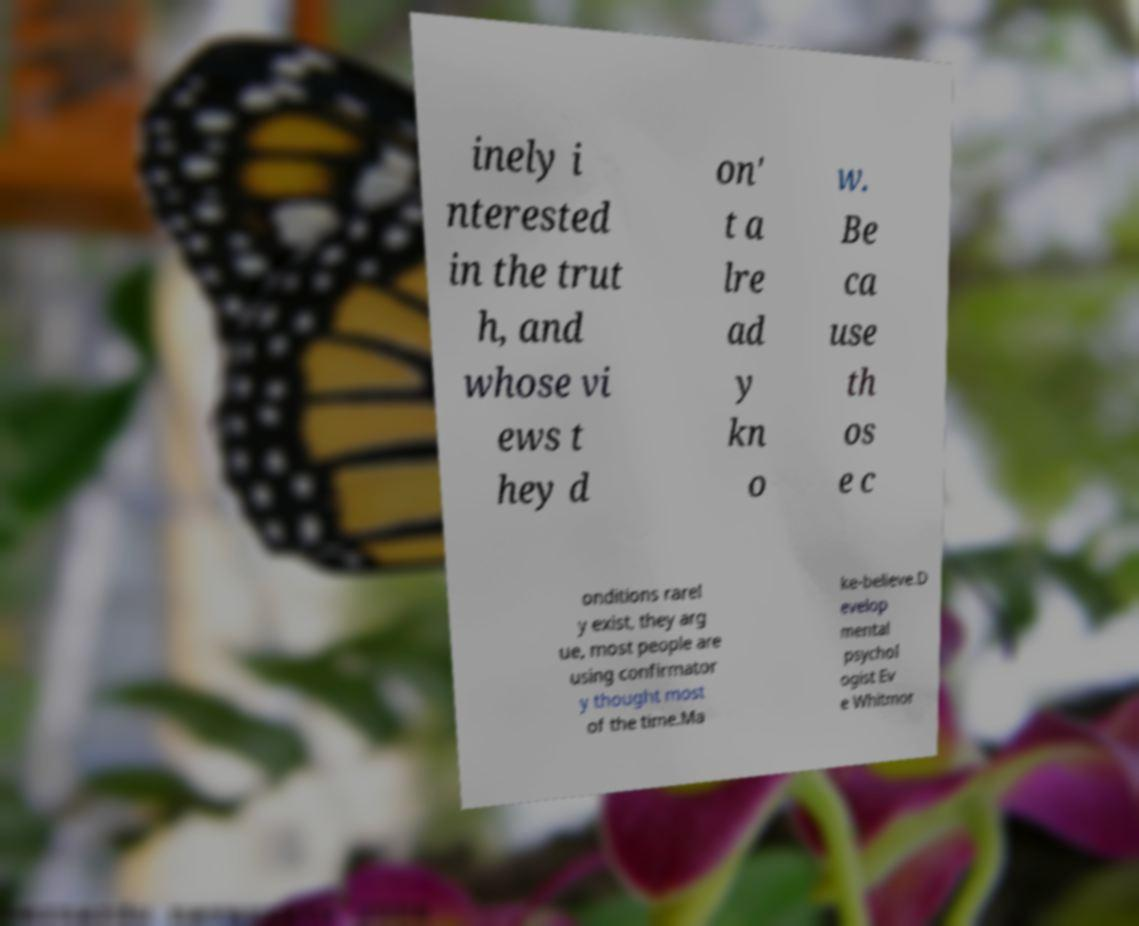I need the written content from this picture converted into text. Can you do that? inely i nterested in the trut h, and whose vi ews t hey d on' t a lre ad y kn o w. Be ca use th os e c onditions rarel y exist, they arg ue, most people are using confirmator y thought most of the time.Ma ke-believe.D evelop mental psychol ogist Ev e Whitmor 